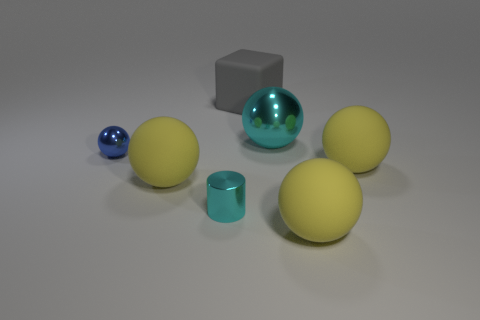Are there any large yellow rubber objects of the same shape as the large cyan object?
Give a very brief answer. Yes. What shape is the thing that is the same size as the blue metallic ball?
Provide a succinct answer. Cylinder. What number of objects are either tiny gray matte blocks or big matte spheres?
Provide a short and direct response. 3. Are there any cyan metallic objects?
Your response must be concise. Yes. Is the number of big rubber things less than the number of rubber cubes?
Your answer should be compact. No. Are there any cyan shiny cylinders of the same size as the matte cube?
Ensure brevity in your answer.  No. Does the tiny blue metallic object have the same shape as the cyan object that is behind the tiny blue shiny ball?
Offer a very short reply. Yes. What number of balls are yellow things or matte things?
Offer a terse response. 3. What is the color of the large metal object?
Make the answer very short. Cyan. Is the number of cyan metallic things greater than the number of gray things?
Your answer should be very brief. Yes. 